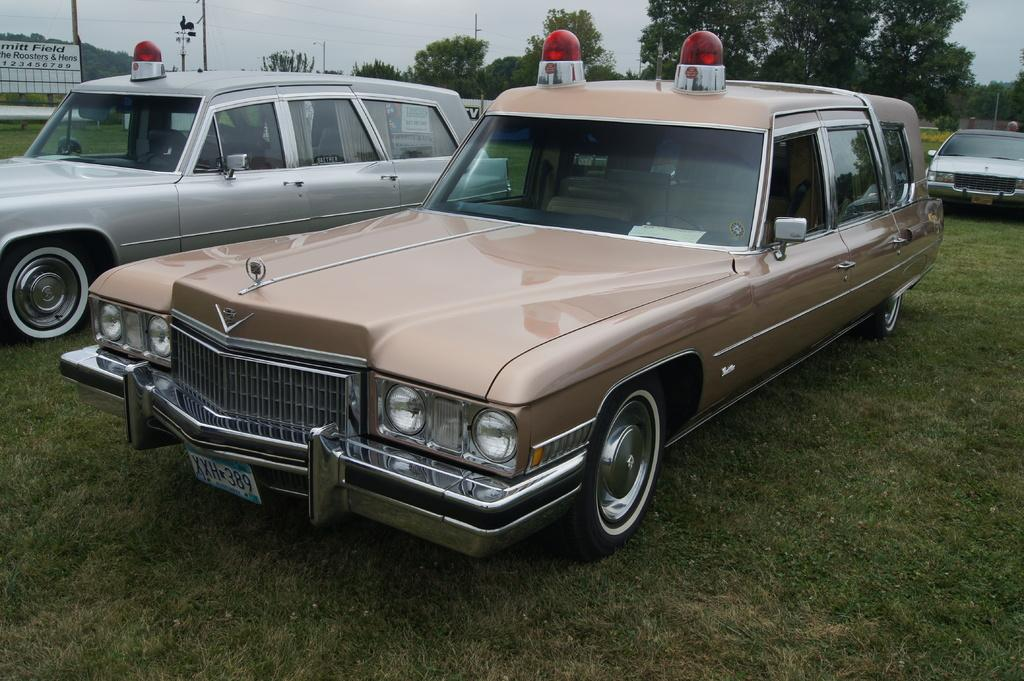What is the unusual location for the parked cars in the image? The cars are parked on the grass in the image. What can be seen in the background of the image? There is a board, signal poles, wires, trees, and the sky visible in the background of the image. What type of committee is meeting in the image? There is no committee meeting in the image; it features parked cars on the grass and various background elements. Can you see any pigs in the image? There are no pigs present in the image. 